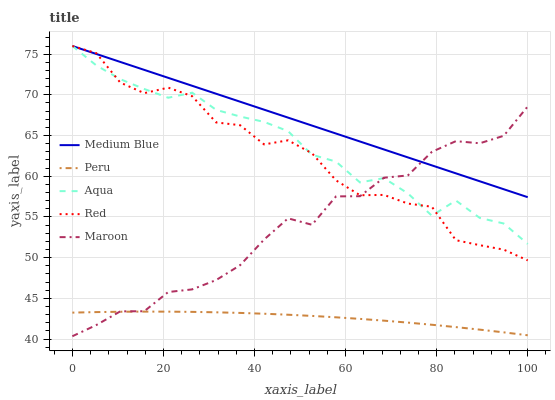Does Peru have the minimum area under the curve?
Answer yes or no. Yes. Does Medium Blue have the maximum area under the curve?
Answer yes or no. Yes. Does Aqua have the minimum area under the curve?
Answer yes or no. No. Does Aqua have the maximum area under the curve?
Answer yes or no. No. Is Medium Blue the smoothest?
Answer yes or no. Yes. Is Red the roughest?
Answer yes or no. Yes. Is Aqua the smoothest?
Answer yes or no. No. Is Aqua the roughest?
Answer yes or no. No. Does Aqua have the lowest value?
Answer yes or no. No. Does Red have the highest value?
Answer yes or no. Yes. Does Peru have the highest value?
Answer yes or no. No. Is Peru less than Medium Blue?
Answer yes or no. Yes. Is Red greater than Peru?
Answer yes or no. Yes. Does Peru intersect Medium Blue?
Answer yes or no. No. 